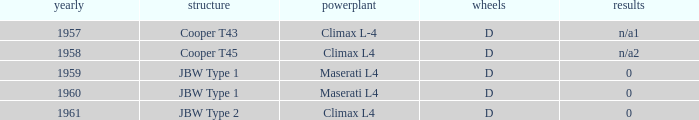Write the full table. {'header': ['yearly', 'structure', 'powerplant', 'wheels', 'results'], 'rows': [['1957', 'Cooper T43', 'Climax L-4', 'D', 'n/a1'], ['1958', 'Cooper T45', 'Climax L4', 'D', 'n/a2'], ['1959', 'JBW Type 1', 'Maserati L4', 'D', '0'], ['1960', 'JBW Type 1', 'Maserati L4', 'D', '0'], ['1961', 'JBW Type 2', 'Climax L4', 'D', '0']]} What company built the chassis for a year later than 1959 and a climax l4 engine? JBW Type 2. 